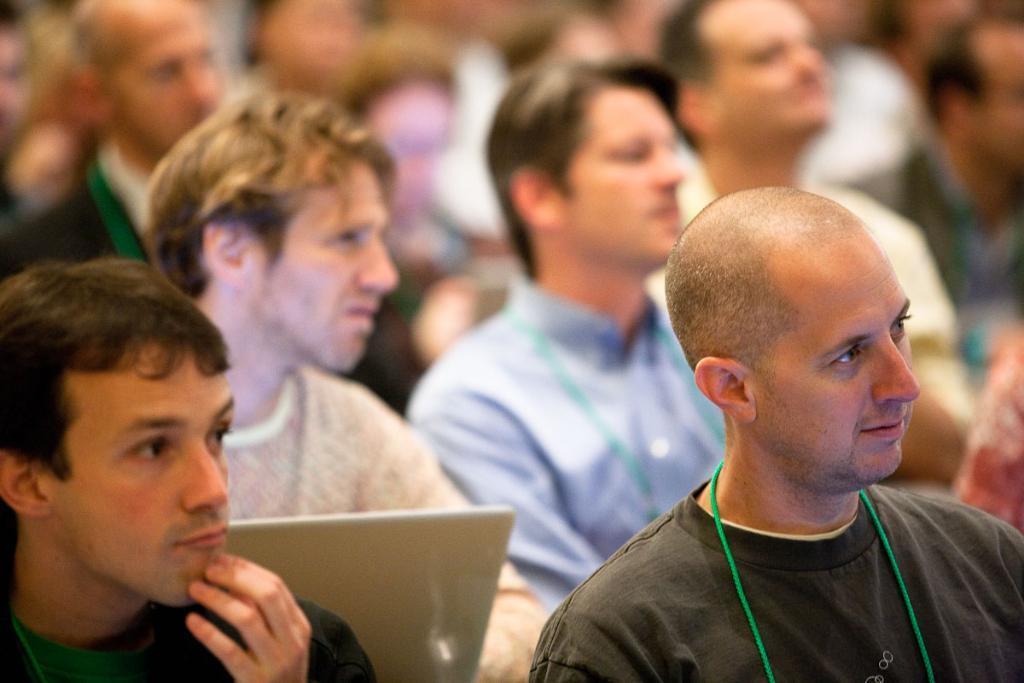Please provide a concise description of this image. In this image I can see a group of men are there, they are looking at the right side. On the left side there is a man holding a laptop. 